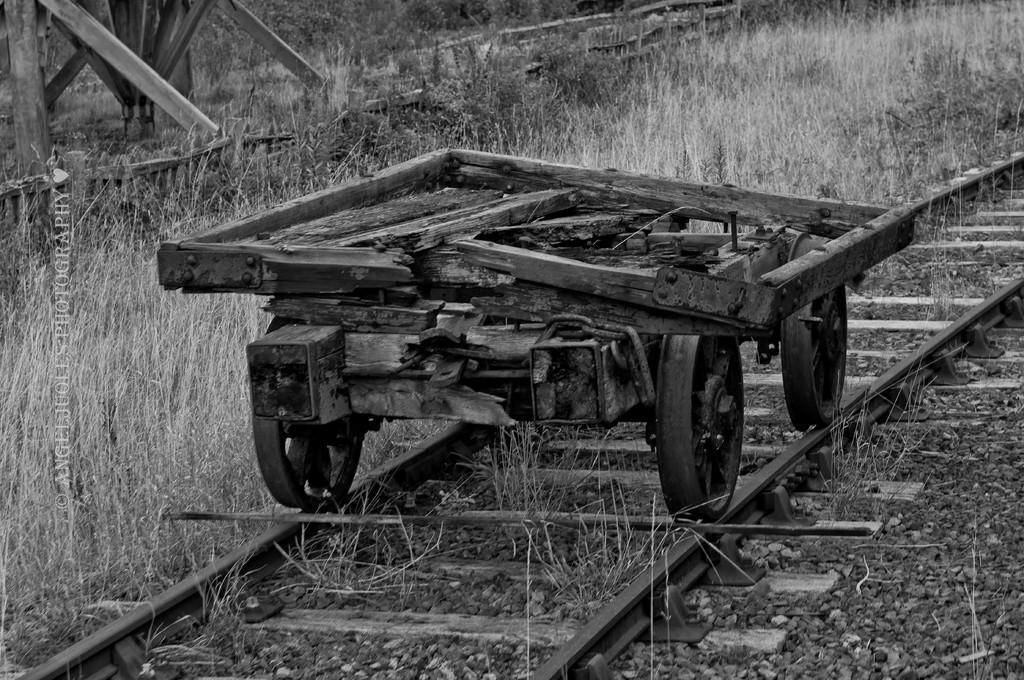How would you summarize this image in a sentence or two? There is a broken vehicle on the railway track and there is a stick in front of it and there is grass beside it. 